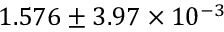<formula> <loc_0><loc_0><loc_500><loc_500>1 . 5 7 6 \pm 3 . 9 7 \times 1 0 ^ { - 3 }</formula> 